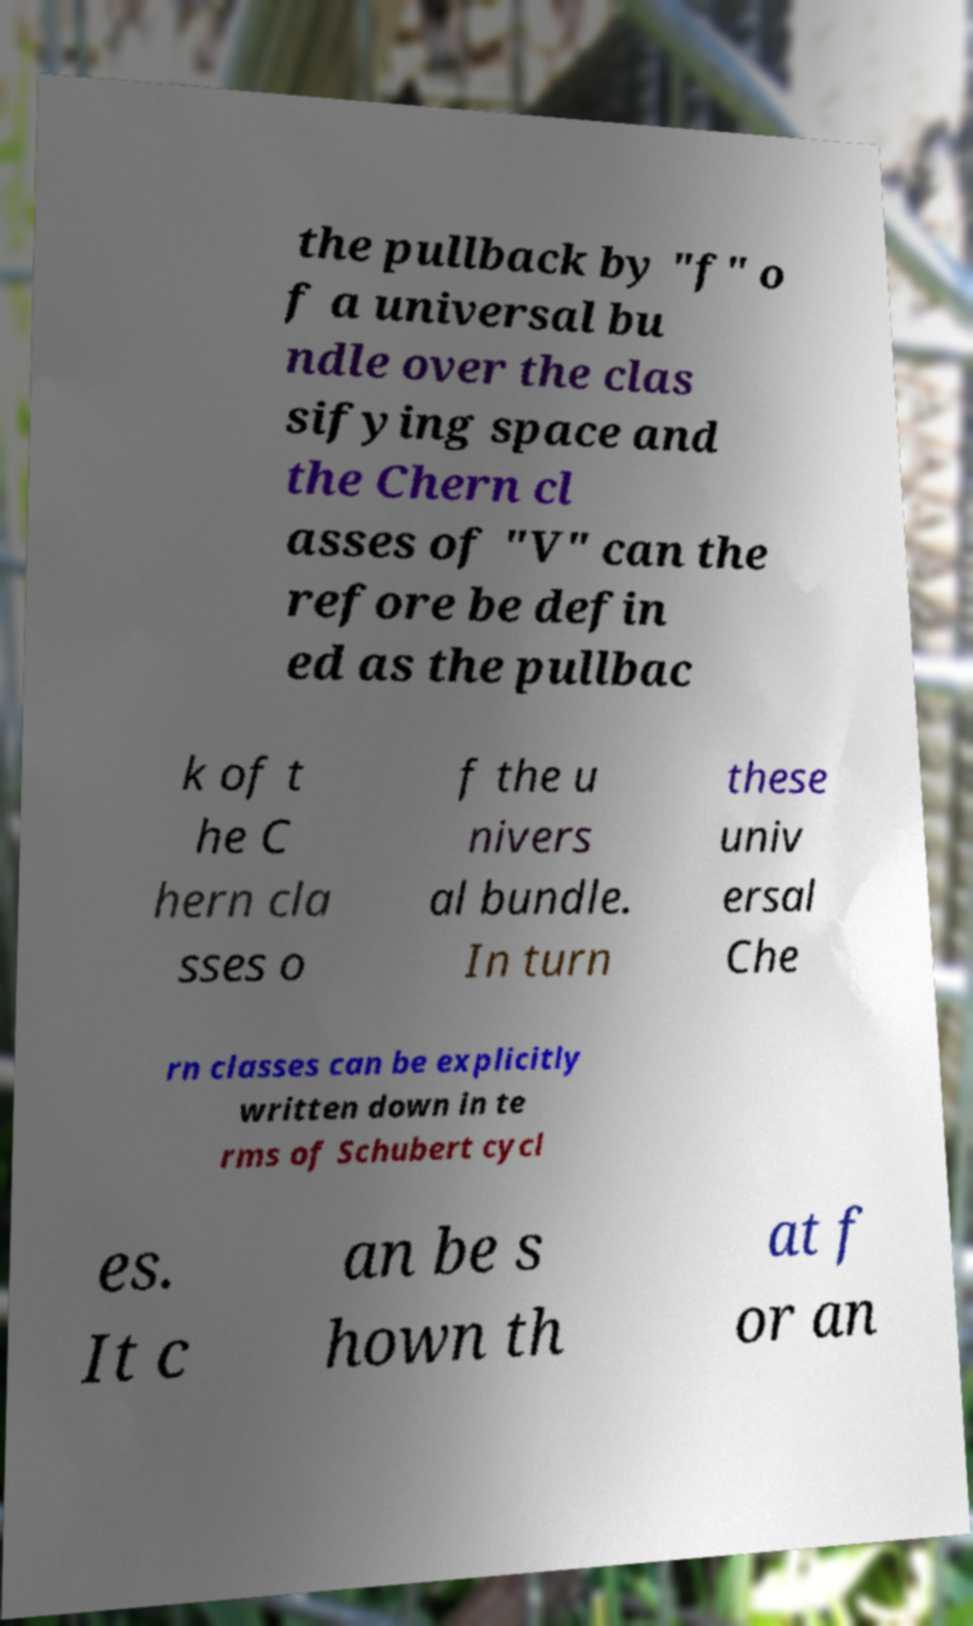There's text embedded in this image that I need extracted. Can you transcribe it verbatim? the pullback by "f" o f a universal bu ndle over the clas sifying space and the Chern cl asses of "V" can the refore be defin ed as the pullbac k of t he C hern cla sses o f the u nivers al bundle. In turn these univ ersal Che rn classes can be explicitly written down in te rms of Schubert cycl es. It c an be s hown th at f or an 